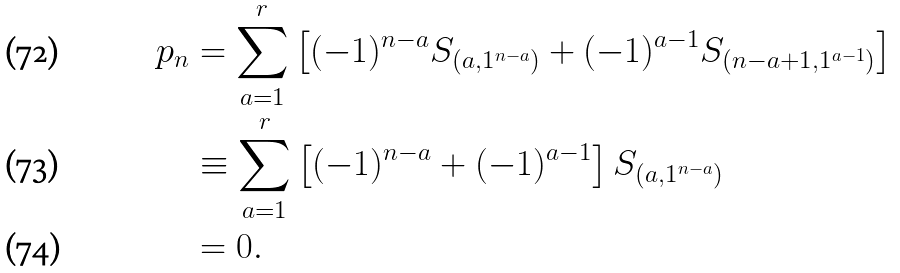<formula> <loc_0><loc_0><loc_500><loc_500>p _ { n } & = \sum _ { a = 1 } ^ { r } \left [ ( - 1 ) ^ { n - a } S _ { ( a , 1 ^ { n - a } ) } + ( - 1 ) ^ { a - 1 } S _ { ( n - a + 1 , 1 ^ { a - 1 } ) } \right ] \\ & \equiv \sum _ { a = 1 } ^ { r } \left [ ( - 1 ) ^ { n - a } + ( - 1 ) ^ { a - 1 } \right ] S _ { ( a , 1 ^ { n - a } ) } \\ & = 0 .</formula> 